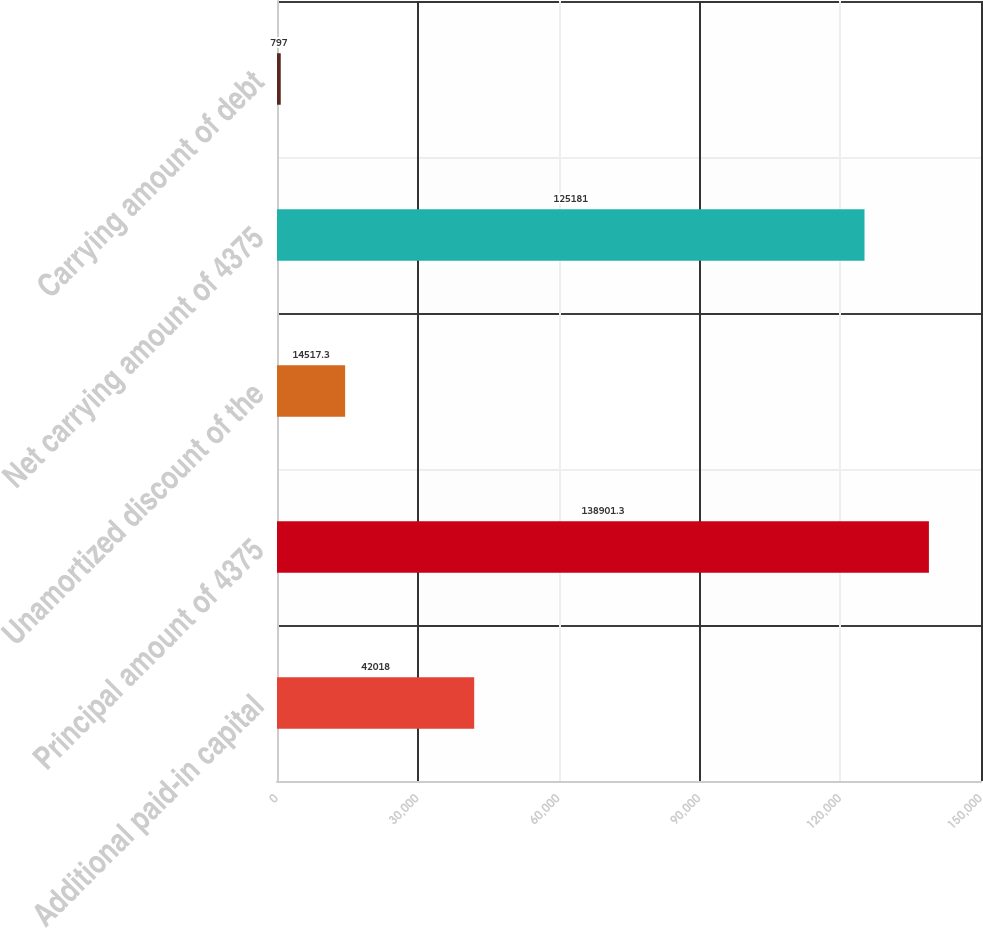<chart> <loc_0><loc_0><loc_500><loc_500><bar_chart><fcel>Additional paid-in capital<fcel>Principal amount of 4375<fcel>Unamortized discount of the<fcel>Net carrying amount of 4375<fcel>Carrying amount of debt<nl><fcel>42018<fcel>138901<fcel>14517.3<fcel>125181<fcel>797<nl></chart> 